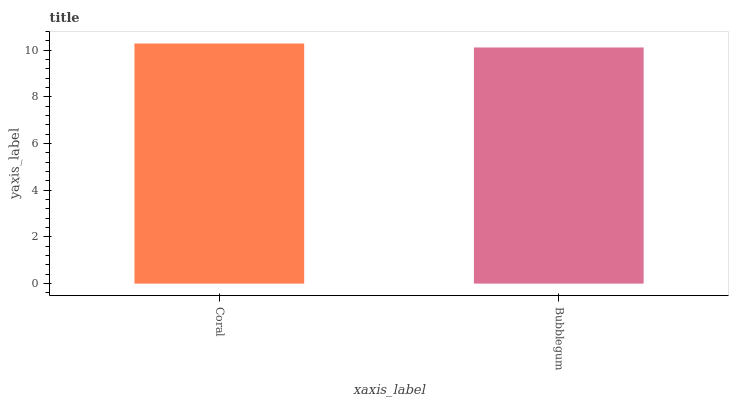Is Bubblegum the minimum?
Answer yes or no. Yes. Is Coral the maximum?
Answer yes or no. Yes. Is Bubblegum the maximum?
Answer yes or no. No. Is Coral greater than Bubblegum?
Answer yes or no. Yes. Is Bubblegum less than Coral?
Answer yes or no. Yes. Is Bubblegum greater than Coral?
Answer yes or no. No. Is Coral less than Bubblegum?
Answer yes or no. No. Is Coral the high median?
Answer yes or no. Yes. Is Bubblegum the low median?
Answer yes or no. Yes. Is Bubblegum the high median?
Answer yes or no. No. Is Coral the low median?
Answer yes or no. No. 